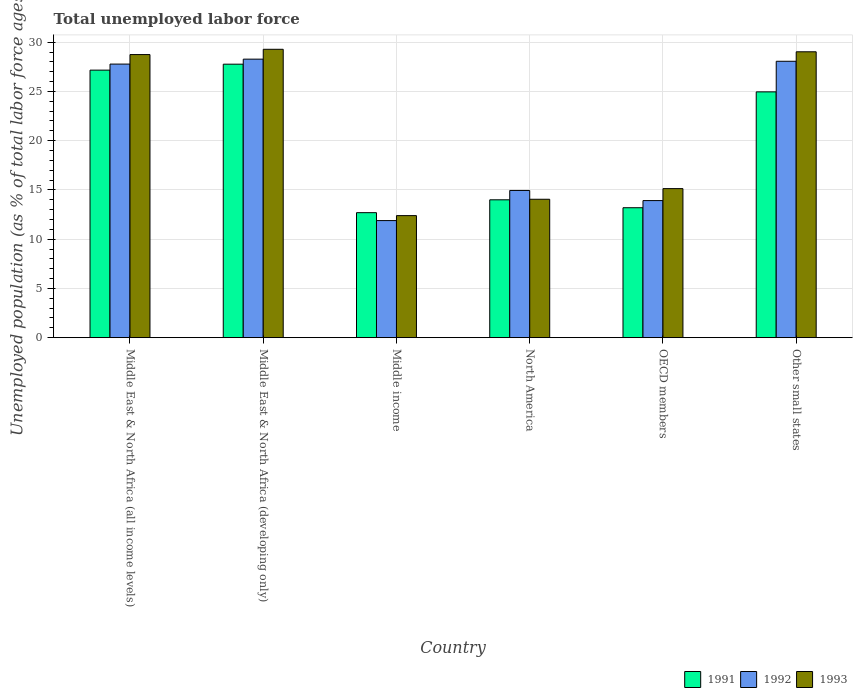How many different coloured bars are there?
Keep it short and to the point. 3. How many groups of bars are there?
Keep it short and to the point. 6. Are the number of bars on each tick of the X-axis equal?
Your answer should be compact. Yes. How many bars are there on the 5th tick from the right?
Provide a succinct answer. 3. What is the label of the 6th group of bars from the left?
Your answer should be compact. Other small states. What is the percentage of unemployed population in in 1993 in Middle East & North Africa (developing only)?
Keep it short and to the point. 29.28. Across all countries, what is the maximum percentage of unemployed population in in 1992?
Keep it short and to the point. 28.28. Across all countries, what is the minimum percentage of unemployed population in in 1993?
Your answer should be very brief. 12.39. In which country was the percentage of unemployed population in in 1991 maximum?
Provide a short and direct response. Middle East & North Africa (developing only). What is the total percentage of unemployed population in in 1991 in the graph?
Provide a short and direct response. 119.77. What is the difference between the percentage of unemployed population in in 1992 in Middle income and that in Other small states?
Give a very brief answer. -16.18. What is the difference between the percentage of unemployed population in in 1993 in North America and the percentage of unemployed population in in 1991 in Other small states?
Ensure brevity in your answer.  -10.9. What is the average percentage of unemployed population in in 1991 per country?
Your answer should be compact. 19.96. What is the difference between the percentage of unemployed population in of/in 1992 and percentage of unemployed population in of/in 1993 in Middle East & North Africa (developing only)?
Give a very brief answer. -1. In how many countries, is the percentage of unemployed population in in 1993 greater than 22 %?
Your answer should be very brief. 3. What is the ratio of the percentage of unemployed population in in 1991 in Middle East & North Africa (all income levels) to that in Other small states?
Make the answer very short. 1.09. Is the difference between the percentage of unemployed population in in 1992 in Middle East & North Africa (developing only) and Middle income greater than the difference between the percentage of unemployed population in in 1993 in Middle East & North Africa (developing only) and Middle income?
Provide a succinct answer. No. What is the difference between the highest and the second highest percentage of unemployed population in in 1991?
Your response must be concise. 2.21. What is the difference between the highest and the lowest percentage of unemployed population in in 1991?
Your answer should be compact. 15.08. In how many countries, is the percentage of unemployed population in in 1992 greater than the average percentage of unemployed population in in 1992 taken over all countries?
Offer a terse response. 3. Is the sum of the percentage of unemployed population in in 1993 in North America and OECD members greater than the maximum percentage of unemployed population in in 1991 across all countries?
Offer a terse response. Yes. What does the 2nd bar from the left in Middle East & North Africa (developing only) represents?
Your answer should be very brief. 1992. What does the 2nd bar from the right in Middle East & North Africa (developing only) represents?
Your answer should be very brief. 1992. Is it the case that in every country, the sum of the percentage of unemployed population in in 1993 and percentage of unemployed population in in 1992 is greater than the percentage of unemployed population in in 1991?
Provide a succinct answer. Yes. How many bars are there?
Keep it short and to the point. 18. Are all the bars in the graph horizontal?
Ensure brevity in your answer.  No. How many countries are there in the graph?
Your response must be concise. 6. What is the difference between two consecutive major ticks on the Y-axis?
Give a very brief answer. 5. Where does the legend appear in the graph?
Provide a short and direct response. Bottom right. How many legend labels are there?
Make the answer very short. 3. What is the title of the graph?
Make the answer very short. Total unemployed labor force. Does "1985" appear as one of the legend labels in the graph?
Provide a short and direct response. No. What is the label or title of the Y-axis?
Keep it short and to the point. Unemployed population (as % of total labor force ages 15-24). What is the Unemployed population (as % of total labor force ages 15-24) in 1991 in Middle East & North Africa (all income levels)?
Provide a succinct answer. 27.16. What is the Unemployed population (as % of total labor force ages 15-24) of 1992 in Middle East & North Africa (all income levels)?
Keep it short and to the point. 27.78. What is the Unemployed population (as % of total labor force ages 15-24) of 1993 in Middle East & North Africa (all income levels)?
Your answer should be very brief. 28.74. What is the Unemployed population (as % of total labor force ages 15-24) of 1991 in Middle East & North Africa (developing only)?
Offer a very short reply. 27.77. What is the Unemployed population (as % of total labor force ages 15-24) of 1992 in Middle East & North Africa (developing only)?
Give a very brief answer. 28.28. What is the Unemployed population (as % of total labor force ages 15-24) in 1993 in Middle East & North Africa (developing only)?
Offer a very short reply. 29.28. What is the Unemployed population (as % of total labor force ages 15-24) in 1991 in Middle income?
Make the answer very short. 12.69. What is the Unemployed population (as % of total labor force ages 15-24) in 1992 in Middle income?
Offer a terse response. 11.89. What is the Unemployed population (as % of total labor force ages 15-24) in 1993 in Middle income?
Offer a terse response. 12.39. What is the Unemployed population (as % of total labor force ages 15-24) in 1991 in North America?
Your response must be concise. 14. What is the Unemployed population (as % of total labor force ages 15-24) of 1992 in North America?
Provide a short and direct response. 14.95. What is the Unemployed population (as % of total labor force ages 15-24) of 1993 in North America?
Your answer should be compact. 14.05. What is the Unemployed population (as % of total labor force ages 15-24) in 1991 in OECD members?
Give a very brief answer. 13.19. What is the Unemployed population (as % of total labor force ages 15-24) of 1992 in OECD members?
Offer a very short reply. 13.92. What is the Unemployed population (as % of total labor force ages 15-24) of 1993 in OECD members?
Make the answer very short. 15.13. What is the Unemployed population (as % of total labor force ages 15-24) of 1991 in Other small states?
Your answer should be very brief. 24.96. What is the Unemployed population (as % of total labor force ages 15-24) of 1992 in Other small states?
Offer a very short reply. 28.06. What is the Unemployed population (as % of total labor force ages 15-24) in 1993 in Other small states?
Make the answer very short. 29.03. Across all countries, what is the maximum Unemployed population (as % of total labor force ages 15-24) in 1991?
Offer a very short reply. 27.77. Across all countries, what is the maximum Unemployed population (as % of total labor force ages 15-24) in 1992?
Ensure brevity in your answer.  28.28. Across all countries, what is the maximum Unemployed population (as % of total labor force ages 15-24) of 1993?
Keep it short and to the point. 29.28. Across all countries, what is the minimum Unemployed population (as % of total labor force ages 15-24) in 1991?
Provide a short and direct response. 12.69. Across all countries, what is the minimum Unemployed population (as % of total labor force ages 15-24) of 1992?
Give a very brief answer. 11.89. Across all countries, what is the minimum Unemployed population (as % of total labor force ages 15-24) in 1993?
Give a very brief answer. 12.39. What is the total Unemployed population (as % of total labor force ages 15-24) in 1991 in the graph?
Offer a very short reply. 119.77. What is the total Unemployed population (as % of total labor force ages 15-24) of 1992 in the graph?
Make the answer very short. 124.87. What is the total Unemployed population (as % of total labor force ages 15-24) of 1993 in the graph?
Keep it short and to the point. 128.63. What is the difference between the Unemployed population (as % of total labor force ages 15-24) of 1991 in Middle East & North Africa (all income levels) and that in Middle East & North Africa (developing only)?
Provide a short and direct response. -0.61. What is the difference between the Unemployed population (as % of total labor force ages 15-24) in 1992 in Middle East & North Africa (all income levels) and that in Middle East & North Africa (developing only)?
Provide a short and direct response. -0.5. What is the difference between the Unemployed population (as % of total labor force ages 15-24) in 1993 in Middle East & North Africa (all income levels) and that in Middle East & North Africa (developing only)?
Make the answer very short. -0.54. What is the difference between the Unemployed population (as % of total labor force ages 15-24) in 1991 in Middle East & North Africa (all income levels) and that in Middle income?
Offer a terse response. 14.47. What is the difference between the Unemployed population (as % of total labor force ages 15-24) of 1992 in Middle East & North Africa (all income levels) and that in Middle income?
Give a very brief answer. 15.89. What is the difference between the Unemployed population (as % of total labor force ages 15-24) of 1993 in Middle East & North Africa (all income levels) and that in Middle income?
Ensure brevity in your answer.  16.35. What is the difference between the Unemployed population (as % of total labor force ages 15-24) in 1991 in Middle East & North Africa (all income levels) and that in North America?
Make the answer very short. 13.17. What is the difference between the Unemployed population (as % of total labor force ages 15-24) in 1992 in Middle East & North Africa (all income levels) and that in North America?
Provide a short and direct response. 12.83. What is the difference between the Unemployed population (as % of total labor force ages 15-24) of 1993 in Middle East & North Africa (all income levels) and that in North America?
Your answer should be very brief. 14.69. What is the difference between the Unemployed population (as % of total labor force ages 15-24) in 1991 in Middle East & North Africa (all income levels) and that in OECD members?
Your answer should be very brief. 13.97. What is the difference between the Unemployed population (as % of total labor force ages 15-24) in 1992 in Middle East & North Africa (all income levels) and that in OECD members?
Ensure brevity in your answer.  13.86. What is the difference between the Unemployed population (as % of total labor force ages 15-24) of 1993 in Middle East & North Africa (all income levels) and that in OECD members?
Keep it short and to the point. 13.61. What is the difference between the Unemployed population (as % of total labor force ages 15-24) in 1991 in Middle East & North Africa (all income levels) and that in Other small states?
Offer a very short reply. 2.21. What is the difference between the Unemployed population (as % of total labor force ages 15-24) in 1992 in Middle East & North Africa (all income levels) and that in Other small states?
Provide a short and direct response. -0.29. What is the difference between the Unemployed population (as % of total labor force ages 15-24) in 1993 in Middle East & North Africa (all income levels) and that in Other small states?
Keep it short and to the point. -0.28. What is the difference between the Unemployed population (as % of total labor force ages 15-24) in 1991 in Middle East & North Africa (developing only) and that in Middle income?
Your answer should be compact. 15.08. What is the difference between the Unemployed population (as % of total labor force ages 15-24) of 1992 in Middle East & North Africa (developing only) and that in Middle income?
Give a very brief answer. 16.39. What is the difference between the Unemployed population (as % of total labor force ages 15-24) of 1993 in Middle East & North Africa (developing only) and that in Middle income?
Give a very brief answer. 16.89. What is the difference between the Unemployed population (as % of total labor force ages 15-24) in 1991 in Middle East & North Africa (developing only) and that in North America?
Provide a short and direct response. 13.77. What is the difference between the Unemployed population (as % of total labor force ages 15-24) in 1992 in Middle East & North Africa (developing only) and that in North America?
Make the answer very short. 13.33. What is the difference between the Unemployed population (as % of total labor force ages 15-24) in 1993 in Middle East & North Africa (developing only) and that in North America?
Ensure brevity in your answer.  15.23. What is the difference between the Unemployed population (as % of total labor force ages 15-24) of 1991 in Middle East & North Africa (developing only) and that in OECD members?
Offer a terse response. 14.58. What is the difference between the Unemployed population (as % of total labor force ages 15-24) in 1992 in Middle East & North Africa (developing only) and that in OECD members?
Make the answer very short. 14.36. What is the difference between the Unemployed population (as % of total labor force ages 15-24) in 1993 in Middle East & North Africa (developing only) and that in OECD members?
Make the answer very short. 14.15. What is the difference between the Unemployed population (as % of total labor force ages 15-24) of 1991 in Middle East & North Africa (developing only) and that in Other small states?
Keep it short and to the point. 2.81. What is the difference between the Unemployed population (as % of total labor force ages 15-24) in 1992 in Middle East & North Africa (developing only) and that in Other small states?
Make the answer very short. 0.22. What is the difference between the Unemployed population (as % of total labor force ages 15-24) of 1993 in Middle East & North Africa (developing only) and that in Other small states?
Your response must be concise. 0.25. What is the difference between the Unemployed population (as % of total labor force ages 15-24) of 1991 in Middle income and that in North America?
Give a very brief answer. -1.3. What is the difference between the Unemployed population (as % of total labor force ages 15-24) in 1992 in Middle income and that in North America?
Offer a terse response. -3.06. What is the difference between the Unemployed population (as % of total labor force ages 15-24) of 1993 in Middle income and that in North America?
Offer a very short reply. -1.66. What is the difference between the Unemployed population (as % of total labor force ages 15-24) of 1991 in Middle income and that in OECD members?
Your response must be concise. -0.5. What is the difference between the Unemployed population (as % of total labor force ages 15-24) of 1992 in Middle income and that in OECD members?
Make the answer very short. -2.03. What is the difference between the Unemployed population (as % of total labor force ages 15-24) in 1993 in Middle income and that in OECD members?
Keep it short and to the point. -2.74. What is the difference between the Unemployed population (as % of total labor force ages 15-24) in 1991 in Middle income and that in Other small states?
Your answer should be very brief. -12.27. What is the difference between the Unemployed population (as % of total labor force ages 15-24) in 1992 in Middle income and that in Other small states?
Offer a terse response. -16.18. What is the difference between the Unemployed population (as % of total labor force ages 15-24) in 1993 in Middle income and that in Other small states?
Give a very brief answer. -16.63. What is the difference between the Unemployed population (as % of total labor force ages 15-24) in 1991 in North America and that in OECD members?
Provide a short and direct response. 0.8. What is the difference between the Unemployed population (as % of total labor force ages 15-24) of 1992 in North America and that in OECD members?
Provide a succinct answer. 1.03. What is the difference between the Unemployed population (as % of total labor force ages 15-24) in 1993 in North America and that in OECD members?
Provide a succinct answer. -1.08. What is the difference between the Unemployed population (as % of total labor force ages 15-24) in 1991 in North America and that in Other small states?
Your answer should be very brief. -10.96. What is the difference between the Unemployed population (as % of total labor force ages 15-24) of 1992 in North America and that in Other small states?
Make the answer very short. -13.12. What is the difference between the Unemployed population (as % of total labor force ages 15-24) of 1993 in North America and that in Other small states?
Provide a short and direct response. -14.97. What is the difference between the Unemployed population (as % of total labor force ages 15-24) in 1991 in OECD members and that in Other small states?
Make the answer very short. -11.77. What is the difference between the Unemployed population (as % of total labor force ages 15-24) of 1992 in OECD members and that in Other small states?
Give a very brief answer. -14.15. What is the difference between the Unemployed population (as % of total labor force ages 15-24) in 1993 in OECD members and that in Other small states?
Your answer should be compact. -13.89. What is the difference between the Unemployed population (as % of total labor force ages 15-24) in 1991 in Middle East & North Africa (all income levels) and the Unemployed population (as % of total labor force ages 15-24) in 1992 in Middle East & North Africa (developing only)?
Provide a succinct answer. -1.12. What is the difference between the Unemployed population (as % of total labor force ages 15-24) in 1991 in Middle East & North Africa (all income levels) and the Unemployed population (as % of total labor force ages 15-24) in 1993 in Middle East & North Africa (developing only)?
Your answer should be very brief. -2.12. What is the difference between the Unemployed population (as % of total labor force ages 15-24) in 1992 in Middle East & North Africa (all income levels) and the Unemployed population (as % of total labor force ages 15-24) in 1993 in Middle East & North Africa (developing only)?
Your response must be concise. -1.5. What is the difference between the Unemployed population (as % of total labor force ages 15-24) of 1991 in Middle East & North Africa (all income levels) and the Unemployed population (as % of total labor force ages 15-24) of 1992 in Middle income?
Your response must be concise. 15.28. What is the difference between the Unemployed population (as % of total labor force ages 15-24) in 1991 in Middle East & North Africa (all income levels) and the Unemployed population (as % of total labor force ages 15-24) in 1993 in Middle income?
Offer a very short reply. 14.77. What is the difference between the Unemployed population (as % of total labor force ages 15-24) of 1992 in Middle East & North Africa (all income levels) and the Unemployed population (as % of total labor force ages 15-24) of 1993 in Middle income?
Provide a succinct answer. 15.39. What is the difference between the Unemployed population (as % of total labor force ages 15-24) of 1991 in Middle East & North Africa (all income levels) and the Unemployed population (as % of total labor force ages 15-24) of 1992 in North America?
Your answer should be compact. 12.22. What is the difference between the Unemployed population (as % of total labor force ages 15-24) in 1991 in Middle East & North Africa (all income levels) and the Unemployed population (as % of total labor force ages 15-24) in 1993 in North America?
Your answer should be very brief. 13.11. What is the difference between the Unemployed population (as % of total labor force ages 15-24) of 1992 in Middle East & North Africa (all income levels) and the Unemployed population (as % of total labor force ages 15-24) of 1993 in North America?
Provide a short and direct response. 13.72. What is the difference between the Unemployed population (as % of total labor force ages 15-24) of 1991 in Middle East & North Africa (all income levels) and the Unemployed population (as % of total labor force ages 15-24) of 1992 in OECD members?
Give a very brief answer. 13.25. What is the difference between the Unemployed population (as % of total labor force ages 15-24) of 1991 in Middle East & North Africa (all income levels) and the Unemployed population (as % of total labor force ages 15-24) of 1993 in OECD members?
Ensure brevity in your answer.  12.03. What is the difference between the Unemployed population (as % of total labor force ages 15-24) in 1992 in Middle East & North Africa (all income levels) and the Unemployed population (as % of total labor force ages 15-24) in 1993 in OECD members?
Provide a succinct answer. 12.64. What is the difference between the Unemployed population (as % of total labor force ages 15-24) in 1991 in Middle East & North Africa (all income levels) and the Unemployed population (as % of total labor force ages 15-24) in 1992 in Other small states?
Give a very brief answer. -0.9. What is the difference between the Unemployed population (as % of total labor force ages 15-24) of 1991 in Middle East & North Africa (all income levels) and the Unemployed population (as % of total labor force ages 15-24) of 1993 in Other small states?
Ensure brevity in your answer.  -1.86. What is the difference between the Unemployed population (as % of total labor force ages 15-24) in 1992 in Middle East & North Africa (all income levels) and the Unemployed population (as % of total labor force ages 15-24) in 1993 in Other small states?
Give a very brief answer. -1.25. What is the difference between the Unemployed population (as % of total labor force ages 15-24) in 1991 in Middle East & North Africa (developing only) and the Unemployed population (as % of total labor force ages 15-24) in 1992 in Middle income?
Provide a short and direct response. 15.88. What is the difference between the Unemployed population (as % of total labor force ages 15-24) in 1991 in Middle East & North Africa (developing only) and the Unemployed population (as % of total labor force ages 15-24) in 1993 in Middle income?
Make the answer very short. 15.38. What is the difference between the Unemployed population (as % of total labor force ages 15-24) in 1992 in Middle East & North Africa (developing only) and the Unemployed population (as % of total labor force ages 15-24) in 1993 in Middle income?
Your answer should be compact. 15.89. What is the difference between the Unemployed population (as % of total labor force ages 15-24) of 1991 in Middle East & North Africa (developing only) and the Unemployed population (as % of total labor force ages 15-24) of 1992 in North America?
Provide a succinct answer. 12.82. What is the difference between the Unemployed population (as % of total labor force ages 15-24) of 1991 in Middle East & North Africa (developing only) and the Unemployed population (as % of total labor force ages 15-24) of 1993 in North America?
Make the answer very short. 13.72. What is the difference between the Unemployed population (as % of total labor force ages 15-24) of 1992 in Middle East & North Africa (developing only) and the Unemployed population (as % of total labor force ages 15-24) of 1993 in North America?
Keep it short and to the point. 14.23. What is the difference between the Unemployed population (as % of total labor force ages 15-24) of 1991 in Middle East & North Africa (developing only) and the Unemployed population (as % of total labor force ages 15-24) of 1992 in OECD members?
Your answer should be very brief. 13.85. What is the difference between the Unemployed population (as % of total labor force ages 15-24) of 1991 in Middle East & North Africa (developing only) and the Unemployed population (as % of total labor force ages 15-24) of 1993 in OECD members?
Make the answer very short. 12.63. What is the difference between the Unemployed population (as % of total labor force ages 15-24) of 1992 in Middle East & North Africa (developing only) and the Unemployed population (as % of total labor force ages 15-24) of 1993 in OECD members?
Provide a succinct answer. 13.15. What is the difference between the Unemployed population (as % of total labor force ages 15-24) of 1991 in Middle East & North Africa (developing only) and the Unemployed population (as % of total labor force ages 15-24) of 1992 in Other small states?
Provide a succinct answer. -0.3. What is the difference between the Unemployed population (as % of total labor force ages 15-24) in 1991 in Middle East & North Africa (developing only) and the Unemployed population (as % of total labor force ages 15-24) in 1993 in Other small states?
Provide a short and direct response. -1.26. What is the difference between the Unemployed population (as % of total labor force ages 15-24) in 1992 in Middle East & North Africa (developing only) and the Unemployed population (as % of total labor force ages 15-24) in 1993 in Other small states?
Your response must be concise. -0.75. What is the difference between the Unemployed population (as % of total labor force ages 15-24) of 1991 in Middle income and the Unemployed population (as % of total labor force ages 15-24) of 1992 in North America?
Ensure brevity in your answer.  -2.25. What is the difference between the Unemployed population (as % of total labor force ages 15-24) of 1991 in Middle income and the Unemployed population (as % of total labor force ages 15-24) of 1993 in North America?
Offer a terse response. -1.36. What is the difference between the Unemployed population (as % of total labor force ages 15-24) of 1992 in Middle income and the Unemployed population (as % of total labor force ages 15-24) of 1993 in North America?
Your response must be concise. -2.17. What is the difference between the Unemployed population (as % of total labor force ages 15-24) in 1991 in Middle income and the Unemployed population (as % of total labor force ages 15-24) in 1992 in OECD members?
Your answer should be very brief. -1.23. What is the difference between the Unemployed population (as % of total labor force ages 15-24) of 1991 in Middle income and the Unemployed population (as % of total labor force ages 15-24) of 1993 in OECD members?
Ensure brevity in your answer.  -2.44. What is the difference between the Unemployed population (as % of total labor force ages 15-24) in 1992 in Middle income and the Unemployed population (as % of total labor force ages 15-24) in 1993 in OECD members?
Provide a succinct answer. -3.25. What is the difference between the Unemployed population (as % of total labor force ages 15-24) of 1991 in Middle income and the Unemployed population (as % of total labor force ages 15-24) of 1992 in Other small states?
Offer a terse response. -15.37. What is the difference between the Unemployed population (as % of total labor force ages 15-24) of 1991 in Middle income and the Unemployed population (as % of total labor force ages 15-24) of 1993 in Other small states?
Ensure brevity in your answer.  -16.33. What is the difference between the Unemployed population (as % of total labor force ages 15-24) in 1992 in Middle income and the Unemployed population (as % of total labor force ages 15-24) in 1993 in Other small states?
Your answer should be compact. -17.14. What is the difference between the Unemployed population (as % of total labor force ages 15-24) in 1991 in North America and the Unemployed population (as % of total labor force ages 15-24) in 1992 in OECD members?
Make the answer very short. 0.08. What is the difference between the Unemployed population (as % of total labor force ages 15-24) in 1991 in North America and the Unemployed population (as % of total labor force ages 15-24) in 1993 in OECD members?
Make the answer very short. -1.14. What is the difference between the Unemployed population (as % of total labor force ages 15-24) of 1992 in North America and the Unemployed population (as % of total labor force ages 15-24) of 1993 in OECD members?
Make the answer very short. -0.19. What is the difference between the Unemployed population (as % of total labor force ages 15-24) in 1991 in North America and the Unemployed population (as % of total labor force ages 15-24) in 1992 in Other small states?
Ensure brevity in your answer.  -14.07. What is the difference between the Unemployed population (as % of total labor force ages 15-24) in 1991 in North America and the Unemployed population (as % of total labor force ages 15-24) in 1993 in Other small states?
Give a very brief answer. -15.03. What is the difference between the Unemployed population (as % of total labor force ages 15-24) of 1992 in North America and the Unemployed population (as % of total labor force ages 15-24) of 1993 in Other small states?
Offer a terse response. -14.08. What is the difference between the Unemployed population (as % of total labor force ages 15-24) of 1991 in OECD members and the Unemployed population (as % of total labor force ages 15-24) of 1992 in Other small states?
Your response must be concise. -14.87. What is the difference between the Unemployed population (as % of total labor force ages 15-24) of 1991 in OECD members and the Unemployed population (as % of total labor force ages 15-24) of 1993 in Other small states?
Offer a terse response. -15.83. What is the difference between the Unemployed population (as % of total labor force ages 15-24) of 1992 in OECD members and the Unemployed population (as % of total labor force ages 15-24) of 1993 in Other small states?
Offer a very short reply. -15.11. What is the average Unemployed population (as % of total labor force ages 15-24) in 1991 per country?
Make the answer very short. 19.96. What is the average Unemployed population (as % of total labor force ages 15-24) of 1992 per country?
Offer a very short reply. 20.81. What is the average Unemployed population (as % of total labor force ages 15-24) of 1993 per country?
Offer a terse response. 21.44. What is the difference between the Unemployed population (as % of total labor force ages 15-24) of 1991 and Unemployed population (as % of total labor force ages 15-24) of 1992 in Middle East & North Africa (all income levels)?
Offer a terse response. -0.61. What is the difference between the Unemployed population (as % of total labor force ages 15-24) in 1991 and Unemployed population (as % of total labor force ages 15-24) in 1993 in Middle East & North Africa (all income levels)?
Your answer should be compact. -1.58. What is the difference between the Unemployed population (as % of total labor force ages 15-24) of 1992 and Unemployed population (as % of total labor force ages 15-24) of 1993 in Middle East & North Africa (all income levels)?
Your answer should be very brief. -0.97. What is the difference between the Unemployed population (as % of total labor force ages 15-24) in 1991 and Unemployed population (as % of total labor force ages 15-24) in 1992 in Middle East & North Africa (developing only)?
Offer a very short reply. -0.51. What is the difference between the Unemployed population (as % of total labor force ages 15-24) in 1991 and Unemployed population (as % of total labor force ages 15-24) in 1993 in Middle East & North Africa (developing only)?
Provide a short and direct response. -1.51. What is the difference between the Unemployed population (as % of total labor force ages 15-24) of 1992 and Unemployed population (as % of total labor force ages 15-24) of 1993 in Middle East & North Africa (developing only)?
Provide a short and direct response. -1. What is the difference between the Unemployed population (as % of total labor force ages 15-24) in 1991 and Unemployed population (as % of total labor force ages 15-24) in 1992 in Middle income?
Provide a short and direct response. 0.8. What is the difference between the Unemployed population (as % of total labor force ages 15-24) of 1991 and Unemployed population (as % of total labor force ages 15-24) of 1993 in Middle income?
Your response must be concise. 0.3. What is the difference between the Unemployed population (as % of total labor force ages 15-24) in 1992 and Unemployed population (as % of total labor force ages 15-24) in 1993 in Middle income?
Make the answer very short. -0.5. What is the difference between the Unemployed population (as % of total labor force ages 15-24) of 1991 and Unemployed population (as % of total labor force ages 15-24) of 1992 in North America?
Provide a succinct answer. -0.95. What is the difference between the Unemployed population (as % of total labor force ages 15-24) in 1991 and Unemployed population (as % of total labor force ages 15-24) in 1993 in North America?
Your response must be concise. -0.06. What is the difference between the Unemployed population (as % of total labor force ages 15-24) in 1992 and Unemployed population (as % of total labor force ages 15-24) in 1993 in North America?
Your response must be concise. 0.89. What is the difference between the Unemployed population (as % of total labor force ages 15-24) in 1991 and Unemployed population (as % of total labor force ages 15-24) in 1992 in OECD members?
Give a very brief answer. -0.73. What is the difference between the Unemployed population (as % of total labor force ages 15-24) of 1991 and Unemployed population (as % of total labor force ages 15-24) of 1993 in OECD members?
Your answer should be very brief. -1.94. What is the difference between the Unemployed population (as % of total labor force ages 15-24) of 1992 and Unemployed population (as % of total labor force ages 15-24) of 1993 in OECD members?
Give a very brief answer. -1.22. What is the difference between the Unemployed population (as % of total labor force ages 15-24) of 1991 and Unemployed population (as % of total labor force ages 15-24) of 1992 in Other small states?
Make the answer very short. -3.11. What is the difference between the Unemployed population (as % of total labor force ages 15-24) in 1991 and Unemployed population (as % of total labor force ages 15-24) in 1993 in Other small states?
Your answer should be compact. -4.07. What is the difference between the Unemployed population (as % of total labor force ages 15-24) of 1992 and Unemployed population (as % of total labor force ages 15-24) of 1993 in Other small states?
Make the answer very short. -0.96. What is the ratio of the Unemployed population (as % of total labor force ages 15-24) of 1991 in Middle East & North Africa (all income levels) to that in Middle East & North Africa (developing only)?
Provide a short and direct response. 0.98. What is the ratio of the Unemployed population (as % of total labor force ages 15-24) of 1992 in Middle East & North Africa (all income levels) to that in Middle East & North Africa (developing only)?
Provide a succinct answer. 0.98. What is the ratio of the Unemployed population (as % of total labor force ages 15-24) in 1993 in Middle East & North Africa (all income levels) to that in Middle East & North Africa (developing only)?
Offer a terse response. 0.98. What is the ratio of the Unemployed population (as % of total labor force ages 15-24) in 1991 in Middle East & North Africa (all income levels) to that in Middle income?
Ensure brevity in your answer.  2.14. What is the ratio of the Unemployed population (as % of total labor force ages 15-24) of 1992 in Middle East & North Africa (all income levels) to that in Middle income?
Provide a succinct answer. 2.34. What is the ratio of the Unemployed population (as % of total labor force ages 15-24) in 1993 in Middle East & North Africa (all income levels) to that in Middle income?
Provide a succinct answer. 2.32. What is the ratio of the Unemployed population (as % of total labor force ages 15-24) in 1991 in Middle East & North Africa (all income levels) to that in North America?
Make the answer very short. 1.94. What is the ratio of the Unemployed population (as % of total labor force ages 15-24) of 1992 in Middle East & North Africa (all income levels) to that in North America?
Your answer should be very brief. 1.86. What is the ratio of the Unemployed population (as % of total labor force ages 15-24) of 1993 in Middle East & North Africa (all income levels) to that in North America?
Provide a short and direct response. 2.05. What is the ratio of the Unemployed population (as % of total labor force ages 15-24) in 1991 in Middle East & North Africa (all income levels) to that in OECD members?
Give a very brief answer. 2.06. What is the ratio of the Unemployed population (as % of total labor force ages 15-24) of 1992 in Middle East & North Africa (all income levels) to that in OECD members?
Give a very brief answer. 2. What is the ratio of the Unemployed population (as % of total labor force ages 15-24) of 1993 in Middle East & North Africa (all income levels) to that in OECD members?
Offer a terse response. 1.9. What is the ratio of the Unemployed population (as % of total labor force ages 15-24) in 1991 in Middle East & North Africa (all income levels) to that in Other small states?
Provide a succinct answer. 1.09. What is the ratio of the Unemployed population (as % of total labor force ages 15-24) of 1993 in Middle East & North Africa (all income levels) to that in Other small states?
Ensure brevity in your answer.  0.99. What is the ratio of the Unemployed population (as % of total labor force ages 15-24) of 1991 in Middle East & North Africa (developing only) to that in Middle income?
Make the answer very short. 2.19. What is the ratio of the Unemployed population (as % of total labor force ages 15-24) of 1992 in Middle East & North Africa (developing only) to that in Middle income?
Give a very brief answer. 2.38. What is the ratio of the Unemployed population (as % of total labor force ages 15-24) of 1993 in Middle East & North Africa (developing only) to that in Middle income?
Provide a succinct answer. 2.36. What is the ratio of the Unemployed population (as % of total labor force ages 15-24) of 1991 in Middle East & North Africa (developing only) to that in North America?
Make the answer very short. 1.98. What is the ratio of the Unemployed population (as % of total labor force ages 15-24) of 1992 in Middle East & North Africa (developing only) to that in North America?
Your answer should be compact. 1.89. What is the ratio of the Unemployed population (as % of total labor force ages 15-24) in 1993 in Middle East & North Africa (developing only) to that in North America?
Offer a terse response. 2.08. What is the ratio of the Unemployed population (as % of total labor force ages 15-24) in 1991 in Middle East & North Africa (developing only) to that in OECD members?
Keep it short and to the point. 2.1. What is the ratio of the Unemployed population (as % of total labor force ages 15-24) of 1992 in Middle East & North Africa (developing only) to that in OECD members?
Give a very brief answer. 2.03. What is the ratio of the Unemployed population (as % of total labor force ages 15-24) of 1993 in Middle East & North Africa (developing only) to that in OECD members?
Your response must be concise. 1.93. What is the ratio of the Unemployed population (as % of total labor force ages 15-24) of 1991 in Middle East & North Africa (developing only) to that in Other small states?
Make the answer very short. 1.11. What is the ratio of the Unemployed population (as % of total labor force ages 15-24) in 1992 in Middle East & North Africa (developing only) to that in Other small states?
Offer a terse response. 1.01. What is the ratio of the Unemployed population (as % of total labor force ages 15-24) in 1993 in Middle East & North Africa (developing only) to that in Other small states?
Your answer should be very brief. 1.01. What is the ratio of the Unemployed population (as % of total labor force ages 15-24) of 1991 in Middle income to that in North America?
Ensure brevity in your answer.  0.91. What is the ratio of the Unemployed population (as % of total labor force ages 15-24) in 1992 in Middle income to that in North America?
Your answer should be compact. 0.8. What is the ratio of the Unemployed population (as % of total labor force ages 15-24) in 1993 in Middle income to that in North America?
Make the answer very short. 0.88. What is the ratio of the Unemployed population (as % of total labor force ages 15-24) in 1991 in Middle income to that in OECD members?
Provide a succinct answer. 0.96. What is the ratio of the Unemployed population (as % of total labor force ages 15-24) in 1992 in Middle income to that in OECD members?
Offer a very short reply. 0.85. What is the ratio of the Unemployed population (as % of total labor force ages 15-24) of 1993 in Middle income to that in OECD members?
Your answer should be compact. 0.82. What is the ratio of the Unemployed population (as % of total labor force ages 15-24) in 1991 in Middle income to that in Other small states?
Provide a short and direct response. 0.51. What is the ratio of the Unemployed population (as % of total labor force ages 15-24) in 1992 in Middle income to that in Other small states?
Your answer should be compact. 0.42. What is the ratio of the Unemployed population (as % of total labor force ages 15-24) of 1993 in Middle income to that in Other small states?
Your answer should be compact. 0.43. What is the ratio of the Unemployed population (as % of total labor force ages 15-24) of 1991 in North America to that in OECD members?
Offer a terse response. 1.06. What is the ratio of the Unemployed population (as % of total labor force ages 15-24) in 1992 in North America to that in OECD members?
Give a very brief answer. 1.07. What is the ratio of the Unemployed population (as % of total labor force ages 15-24) in 1991 in North America to that in Other small states?
Provide a short and direct response. 0.56. What is the ratio of the Unemployed population (as % of total labor force ages 15-24) in 1992 in North America to that in Other small states?
Offer a very short reply. 0.53. What is the ratio of the Unemployed population (as % of total labor force ages 15-24) of 1993 in North America to that in Other small states?
Offer a terse response. 0.48. What is the ratio of the Unemployed population (as % of total labor force ages 15-24) of 1991 in OECD members to that in Other small states?
Ensure brevity in your answer.  0.53. What is the ratio of the Unemployed population (as % of total labor force ages 15-24) in 1992 in OECD members to that in Other small states?
Give a very brief answer. 0.5. What is the ratio of the Unemployed population (as % of total labor force ages 15-24) in 1993 in OECD members to that in Other small states?
Provide a short and direct response. 0.52. What is the difference between the highest and the second highest Unemployed population (as % of total labor force ages 15-24) in 1991?
Provide a short and direct response. 0.61. What is the difference between the highest and the second highest Unemployed population (as % of total labor force ages 15-24) of 1992?
Offer a very short reply. 0.22. What is the difference between the highest and the second highest Unemployed population (as % of total labor force ages 15-24) of 1993?
Ensure brevity in your answer.  0.25. What is the difference between the highest and the lowest Unemployed population (as % of total labor force ages 15-24) of 1991?
Provide a succinct answer. 15.08. What is the difference between the highest and the lowest Unemployed population (as % of total labor force ages 15-24) of 1992?
Ensure brevity in your answer.  16.39. What is the difference between the highest and the lowest Unemployed population (as % of total labor force ages 15-24) of 1993?
Offer a terse response. 16.89. 